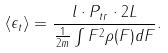Convert formula to latex. <formula><loc_0><loc_0><loc_500><loc_500>\langle \epsilon _ { t } \rangle = \frac { l \cdot P _ { t r } \cdot 2 L } { \frac { 1 } { 2 m } \int F ^ { 2 } \rho ( F ) d F } .</formula> 